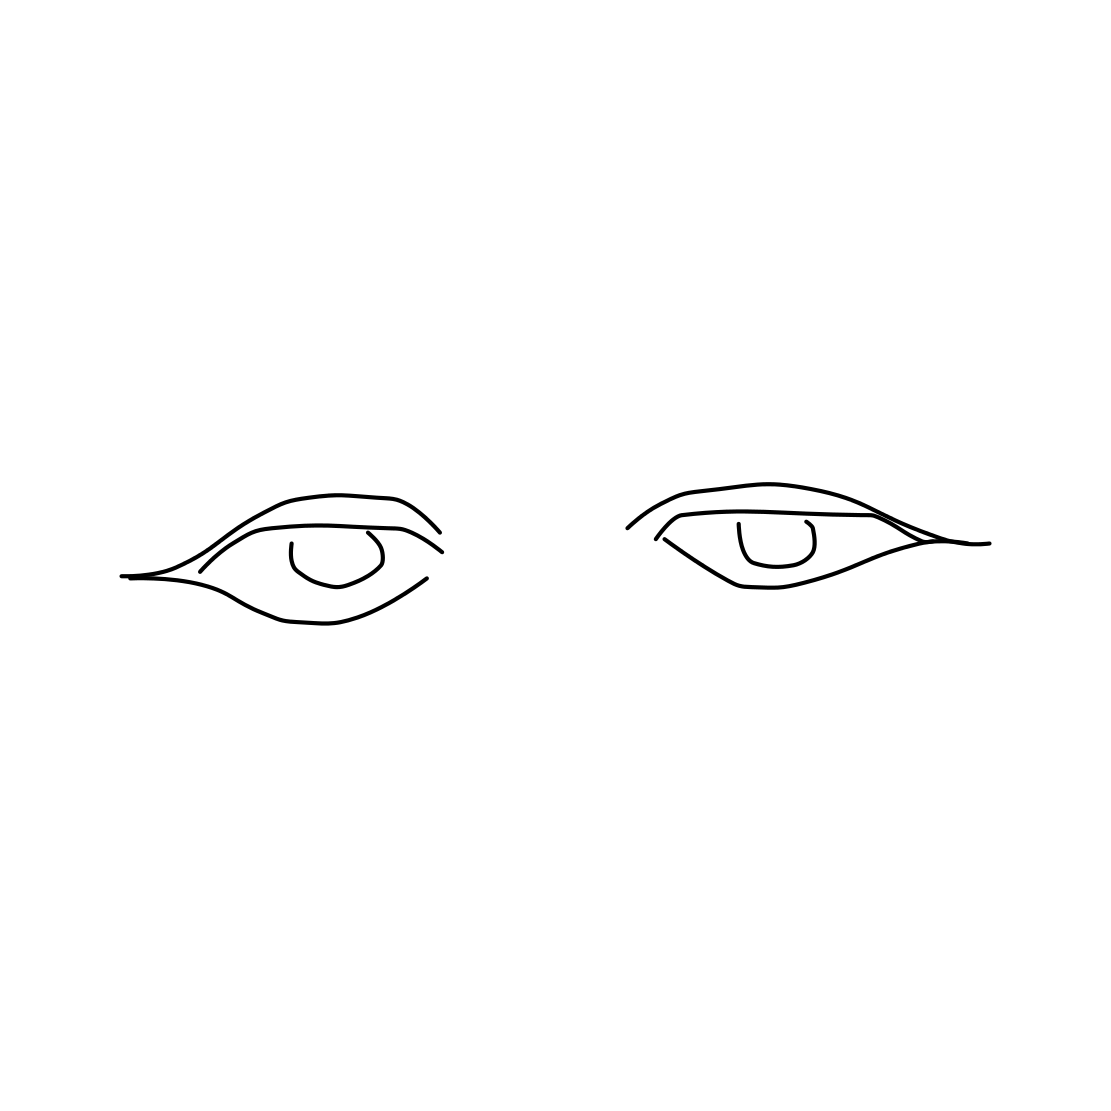Is there a sketchy eye in the picture? Yes 